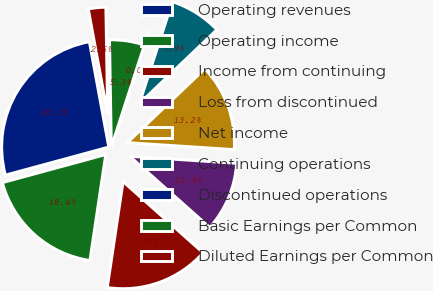Convert chart to OTSL. <chart><loc_0><loc_0><loc_500><loc_500><pie_chart><fcel>Operating revenues<fcel>Operating income<fcel>Income from continuing<fcel>Loss from discontinued<fcel>Net income<fcel>Continuing operations<fcel>Discontinued operations<fcel>Basic Earnings per Common<fcel>Diluted Earnings per Common<nl><fcel>26.32%<fcel>18.42%<fcel>15.79%<fcel>10.53%<fcel>13.16%<fcel>7.89%<fcel>0.0%<fcel>5.26%<fcel>2.63%<nl></chart> 